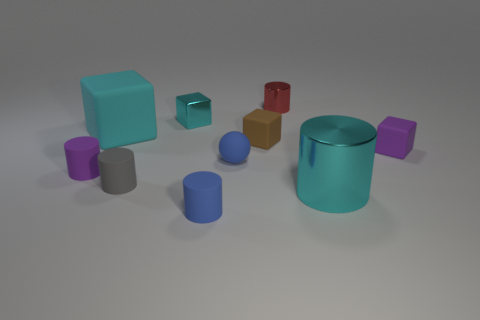Subtract all purple rubber blocks. How many blocks are left? 3 Subtract all red cylinders. How many cyan blocks are left? 2 Subtract all balls. How many objects are left? 9 Subtract 4 cylinders. How many cylinders are left? 1 Subtract all cyan cubes. How many cubes are left? 2 Subtract all purple spheres. Subtract all red blocks. How many spheres are left? 1 Subtract all large gray matte spheres. Subtract all small brown rubber blocks. How many objects are left? 9 Add 3 red things. How many red things are left? 4 Add 1 tiny brown rubber cylinders. How many tiny brown rubber cylinders exist? 1 Subtract 0 cyan balls. How many objects are left? 10 